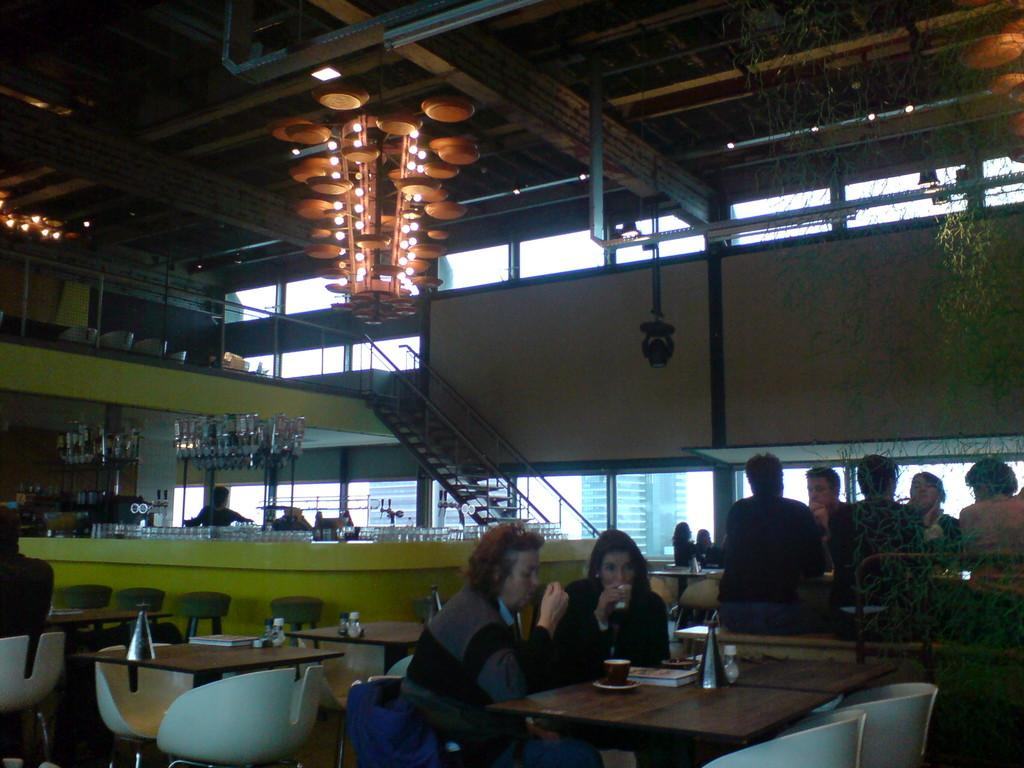What is located on top of the objects in the image? There are lights on top in the image. What are the people in the image doing? The people are sitting on chairs in the image. Can you describe the person who is not sitting? There is a person standing far away in the image. What items can be seen on the table? There are glasses on a table in the image. What type of furniture is visible in the image? Chairs and tables are visible in the image. What architectural feature is present in the image? There are steps in the image. Can you tell me how many pigs are visible in the image? There are no pigs present in the image. What type of jar is being used by the person standing far away? There is no jar visible in the image. 